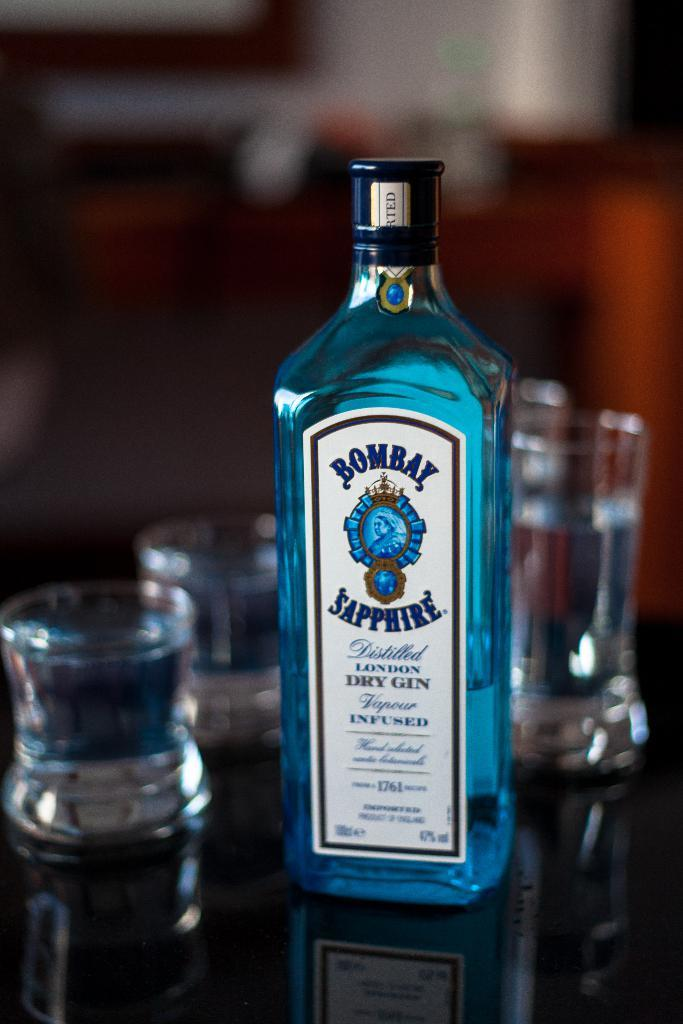<image>
Create a compact narrative representing the image presented. A blue bottle of Bombay Sapphire Dry Gin with shot glasses in the background 